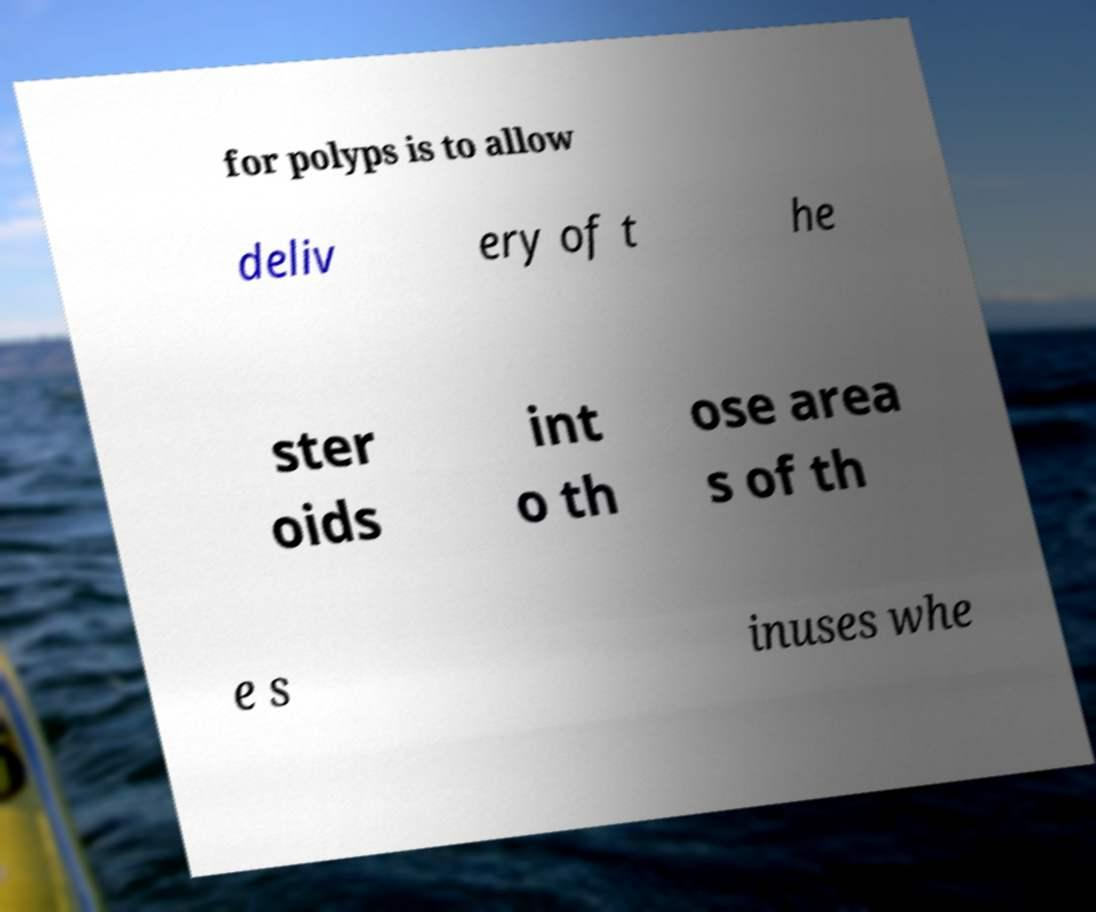There's text embedded in this image that I need extracted. Can you transcribe it verbatim? for polyps is to allow deliv ery of t he ster oids int o th ose area s of th e s inuses whe 